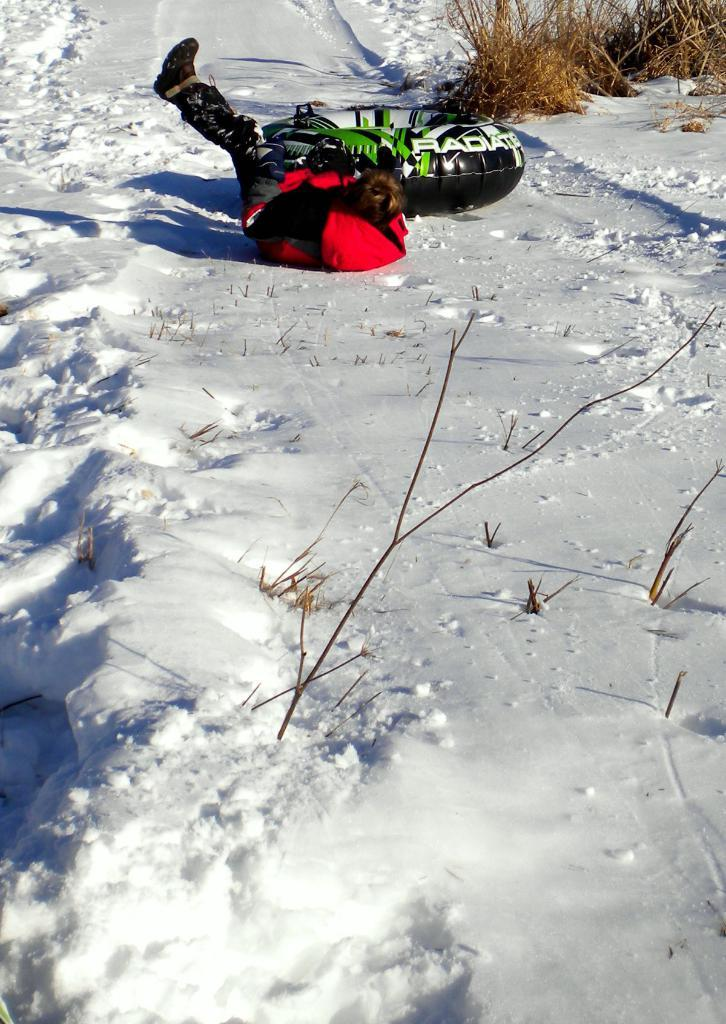What is the person in the image doing? The person is lying on the snow at the top of the image. What is the black object in the image? The facts do not provide information about the black object, so we cannot definitively answer this question. What type of vegetation can be seen in the image? There are plants visible in the top right corner of the image. What is the primary feature of the landscape in the image? The image contains snow, which is the primary feature of the landscape. What is the person's smile like in the image? The facts do not mention anything about the person's facial expression, so we cannot definitively answer this question. 